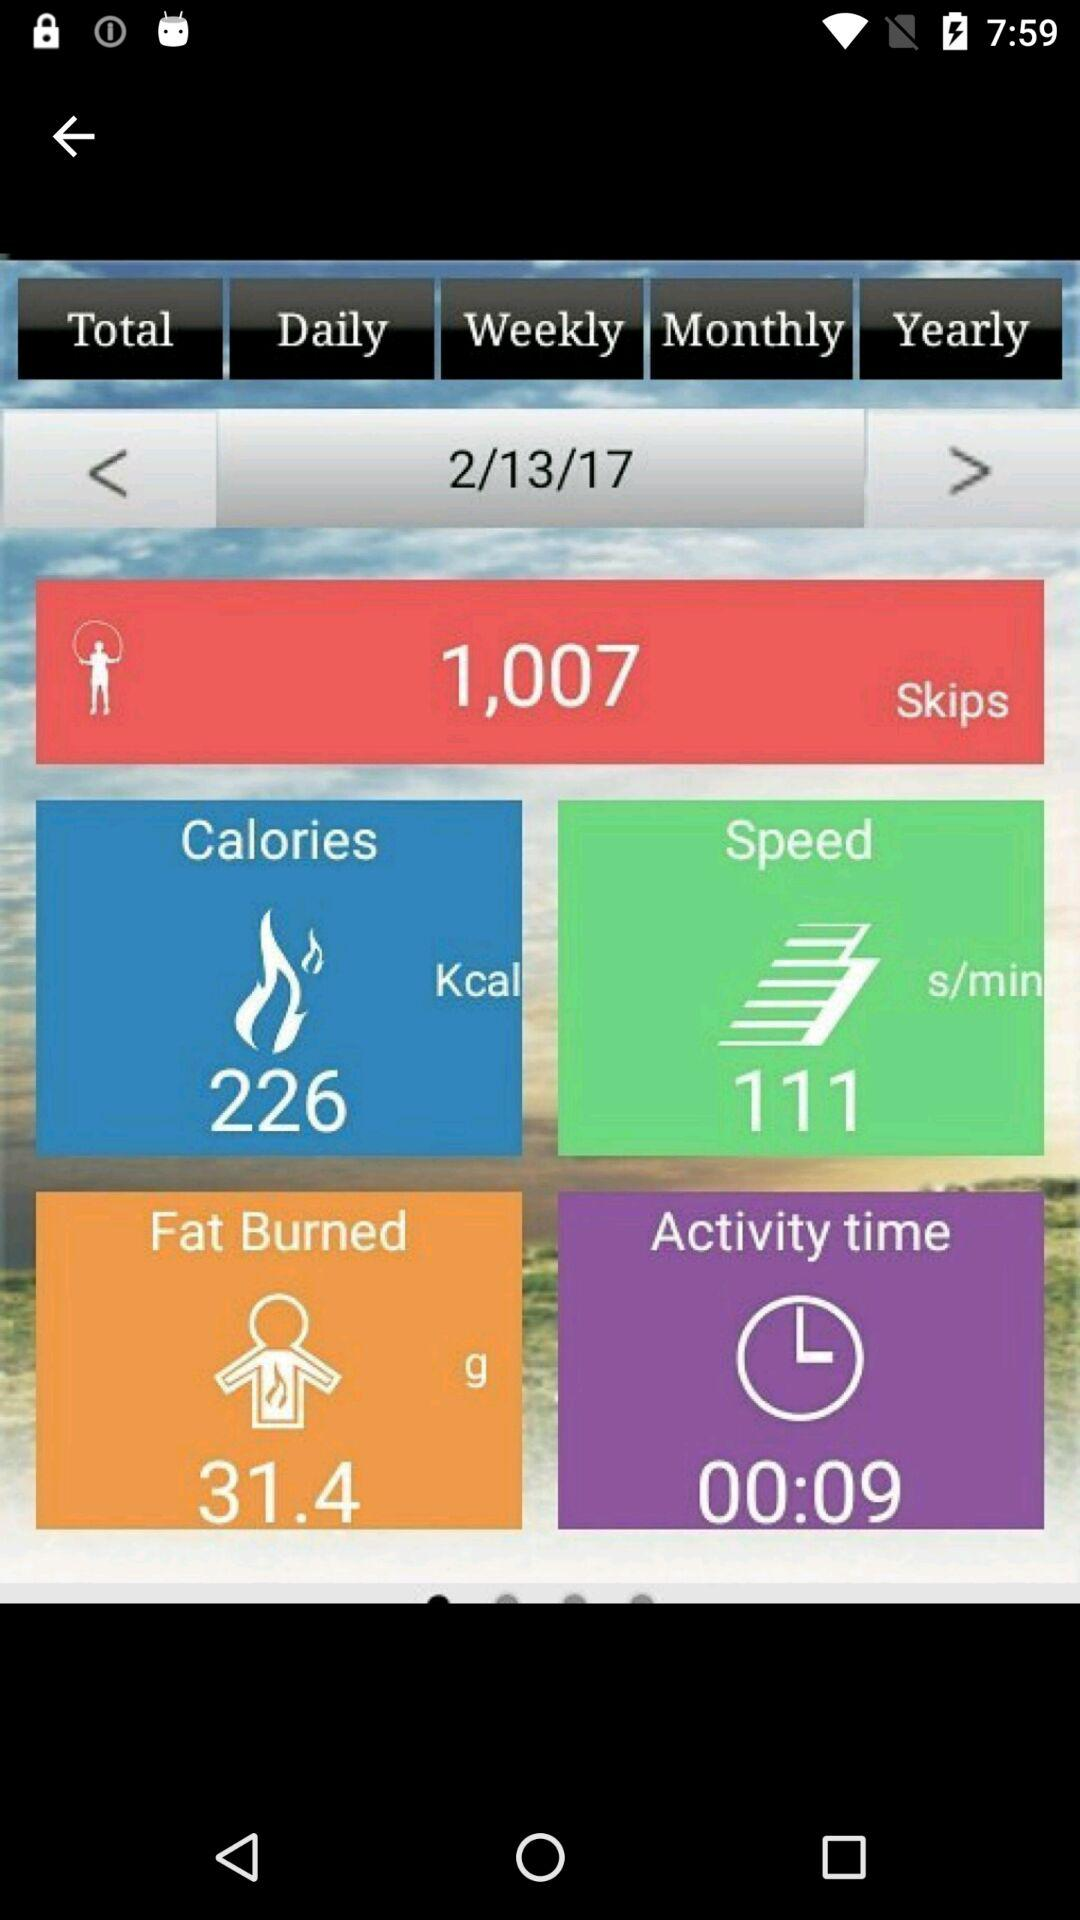Which date data is shown? The shown date is February 13, 2017. 